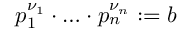<formula> <loc_0><loc_0><loc_500><loc_500>p _ { 1 } ^ { \nu _ { 1 } } \cdot \dots \cdot p _ { n } ^ { \nu _ { n } } \colon = b</formula> 